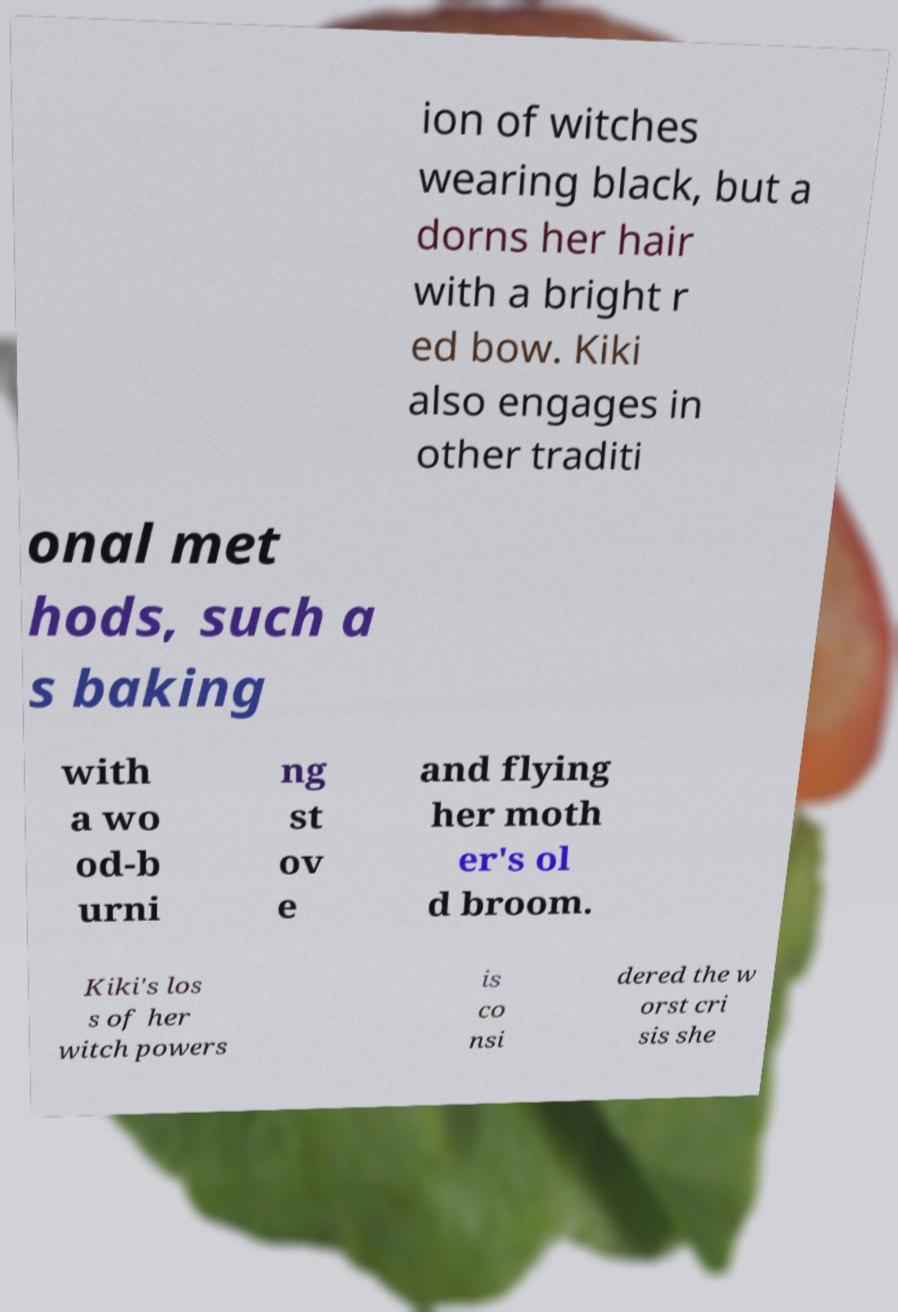What messages or text are displayed in this image? I need them in a readable, typed format. ion of witches wearing black, but a dorns her hair with a bright r ed bow. Kiki also engages in other traditi onal met hods, such a s baking with a wo od-b urni ng st ov e and flying her moth er's ol d broom. Kiki's los s of her witch powers is co nsi dered the w orst cri sis she 